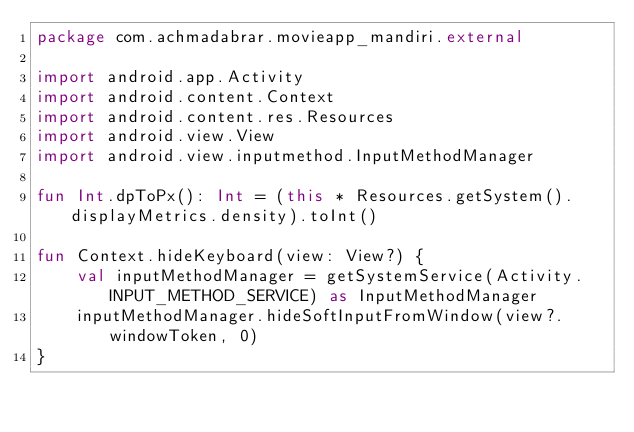<code> <loc_0><loc_0><loc_500><loc_500><_Kotlin_>package com.achmadabrar.movieapp_mandiri.external

import android.app.Activity
import android.content.Context
import android.content.res.Resources
import android.view.View
import android.view.inputmethod.InputMethodManager

fun Int.dpToPx(): Int = (this * Resources.getSystem().displayMetrics.density).toInt()

fun Context.hideKeyboard(view: View?) {
    val inputMethodManager = getSystemService(Activity.INPUT_METHOD_SERVICE) as InputMethodManager
    inputMethodManager.hideSoftInputFromWindow(view?.windowToken, 0)
}
</code> 